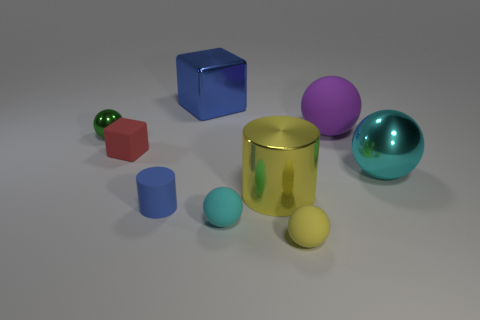What number of large objects are either cyan objects or cyan rubber things?
Your answer should be very brief. 1. The big thing that is the same material as the tiny red thing is what color?
Keep it short and to the point. Purple. Does the rubber thing that is behind the tiny shiny thing have the same shape as the yellow thing that is behind the yellow rubber thing?
Your answer should be compact. No. How many metallic things are large blue blocks or red blocks?
Provide a succinct answer. 1. There is a object that is the same color as the shiny cylinder; what is its material?
Provide a short and direct response. Rubber. Are there any other things that are the same shape as the tiny metallic thing?
Your answer should be compact. Yes. What is the green object that is behind the cyan rubber ball made of?
Offer a very short reply. Metal. Is the material of the cyan sphere in front of the tiny blue thing the same as the big purple sphere?
Ensure brevity in your answer.  Yes. How many objects are either small metallic spheres or cyan objects that are in front of the cyan metal thing?
Your response must be concise. 2. The other cyan object that is the same shape as the cyan shiny thing is what size?
Your response must be concise. Small. 